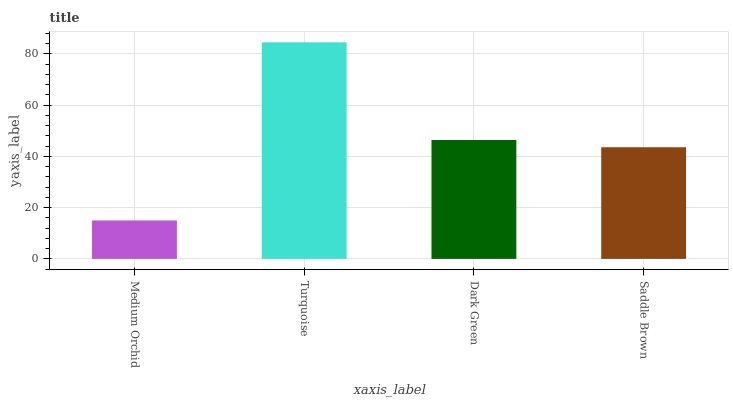Is Medium Orchid the minimum?
Answer yes or no. Yes. Is Turquoise the maximum?
Answer yes or no. Yes. Is Dark Green the minimum?
Answer yes or no. No. Is Dark Green the maximum?
Answer yes or no. No. Is Turquoise greater than Dark Green?
Answer yes or no. Yes. Is Dark Green less than Turquoise?
Answer yes or no. Yes. Is Dark Green greater than Turquoise?
Answer yes or no. No. Is Turquoise less than Dark Green?
Answer yes or no. No. Is Dark Green the high median?
Answer yes or no. Yes. Is Saddle Brown the low median?
Answer yes or no. Yes. Is Medium Orchid the high median?
Answer yes or no. No. Is Dark Green the low median?
Answer yes or no. No. 